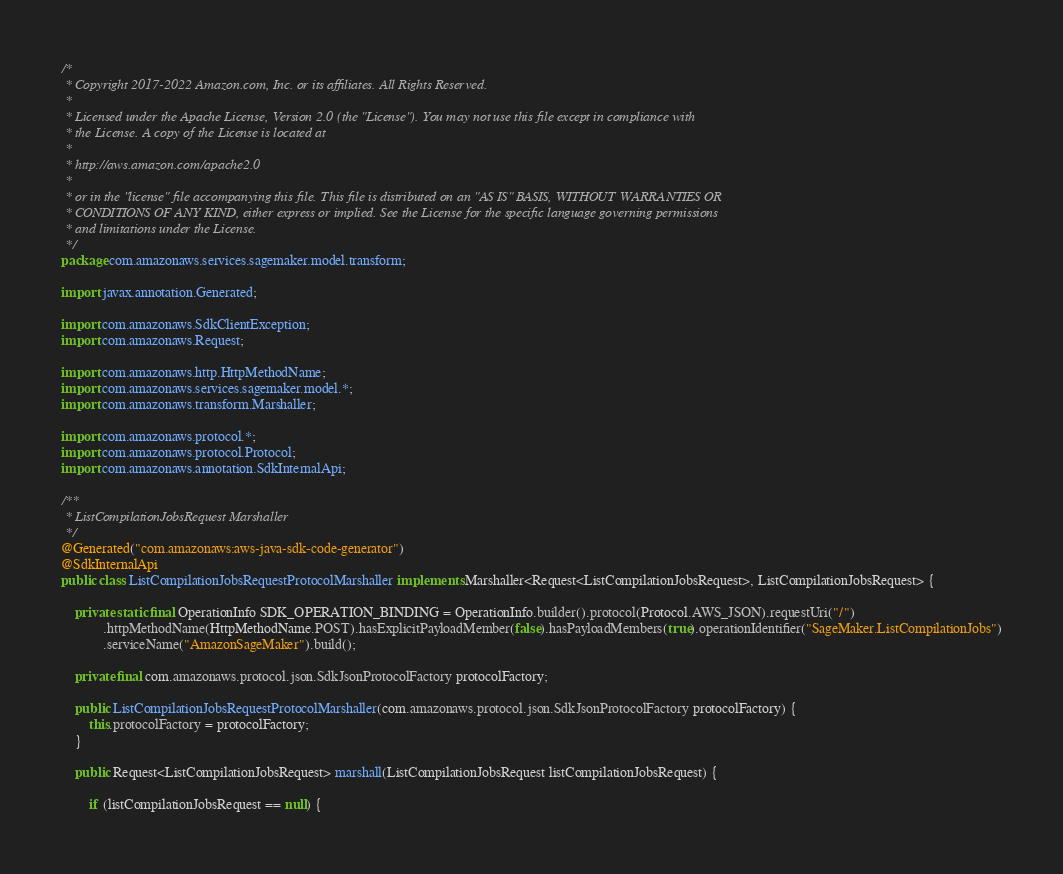<code> <loc_0><loc_0><loc_500><loc_500><_Java_>/*
 * Copyright 2017-2022 Amazon.com, Inc. or its affiliates. All Rights Reserved.
 * 
 * Licensed under the Apache License, Version 2.0 (the "License"). You may not use this file except in compliance with
 * the License. A copy of the License is located at
 * 
 * http://aws.amazon.com/apache2.0
 * 
 * or in the "license" file accompanying this file. This file is distributed on an "AS IS" BASIS, WITHOUT WARRANTIES OR
 * CONDITIONS OF ANY KIND, either express or implied. See the License for the specific language governing permissions
 * and limitations under the License.
 */
package com.amazonaws.services.sagemaker.model.transform;

import javax.annotation.Generated;

import com.amazonaws.SdkClientException;
import com.amazonaws.Request;

import com.amazonaws.http.HttpMethodName;
import com.amazonaws.services.sagemaker.model.*;
import com.amazonaws.transform.Marshaller;

import com.amazonaws.protocol.*;
import com.amazonaws.protocol.Protocol;
import com.amazonaws.annotation.SdkInternalApi;

/**
 * ListCompilationJobsRequest Marshaller
 */
@Generated("com.amazonaws:aws-java-sdk-code-generator")
@SdkInternalApi
public class ListCompilationJobsRequestProtocolMarshaller implements Marshaller<Request<ListCompilationJobsRequest>, ListCompilationJobsRequest> {

    private static final OperationInfo SDK_OPERATION_BINDING = OperationInfo.builder().protocol(Protocol.AWS_JSON).requestUri("/")
            .httpMethodName(HttpMethodName.POST).hasExplicitPayloadMember(false).hasPayloadMembers(true).operationIdentifier("SageMaker.ListCompilationJobs")
            .serviceName("AmazonSageMaker").build();

    private final com.amazonaws.protocol.json.SdkJsonProtocolFactory protocolFactory;

    public ListCompilationJobsRequestProtocolMarshaller(com.amazonaws.protocol.json.SdkJsonProtocolFactory protocolFactory) {
        this.protocolFactory = protocolFactory;
    }

    public Request<ListCompilationJobsRequest> marshall(ListCompilationJobsRequest listCompilationJobsRequest) {

        if (listCompilationJobsRequest == null) {</code> 